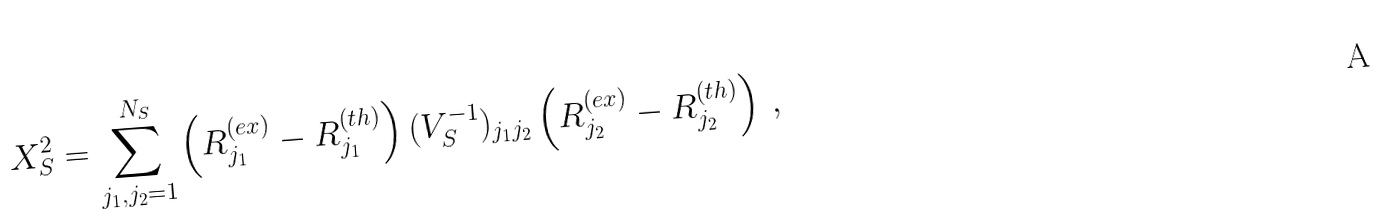<formula> <loc_0><loc_0><loc_500><loc_500>X ^ { 2 } _ { S } = \sum _ { j _ { 1 } , j _ { 2 } = 1 } ^ { N _ { S } } \left ( R ^ { ( e x ) } _ { j _ { 1 } } - R ^ { ( t h ) } _ { j _ { 1 } } \right ) ( V ^ { - 1 } _ { S } ) _ { j _ { 1 } j _ { 2 } } \left ( R ^ { ( e x ) } _ { j _ { 2 } } - R ^ { ( t h ) } _ { j _ { 2 } } \right ) \, ,</formula> 